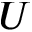Convert formula to latex. <formula><loc_0><loc_0><loc_500><loc_500>U</formula> 